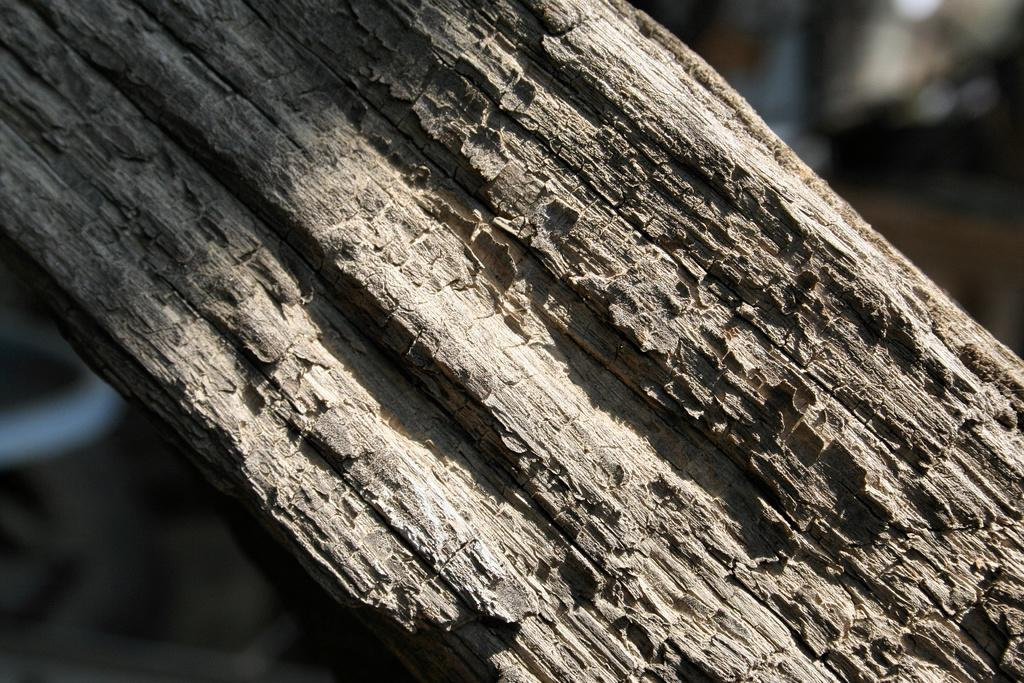What is the main subject of the image? The main subject of the image is the trunk of a tree. What type of marble is used to decorate the trunk of the tree in the image? There is no marble present in the image; it features only the trunk of a tree. What action is the tree trunk performing in the image? The tree trunk is not performing any action in the image; it is a stationary object. 